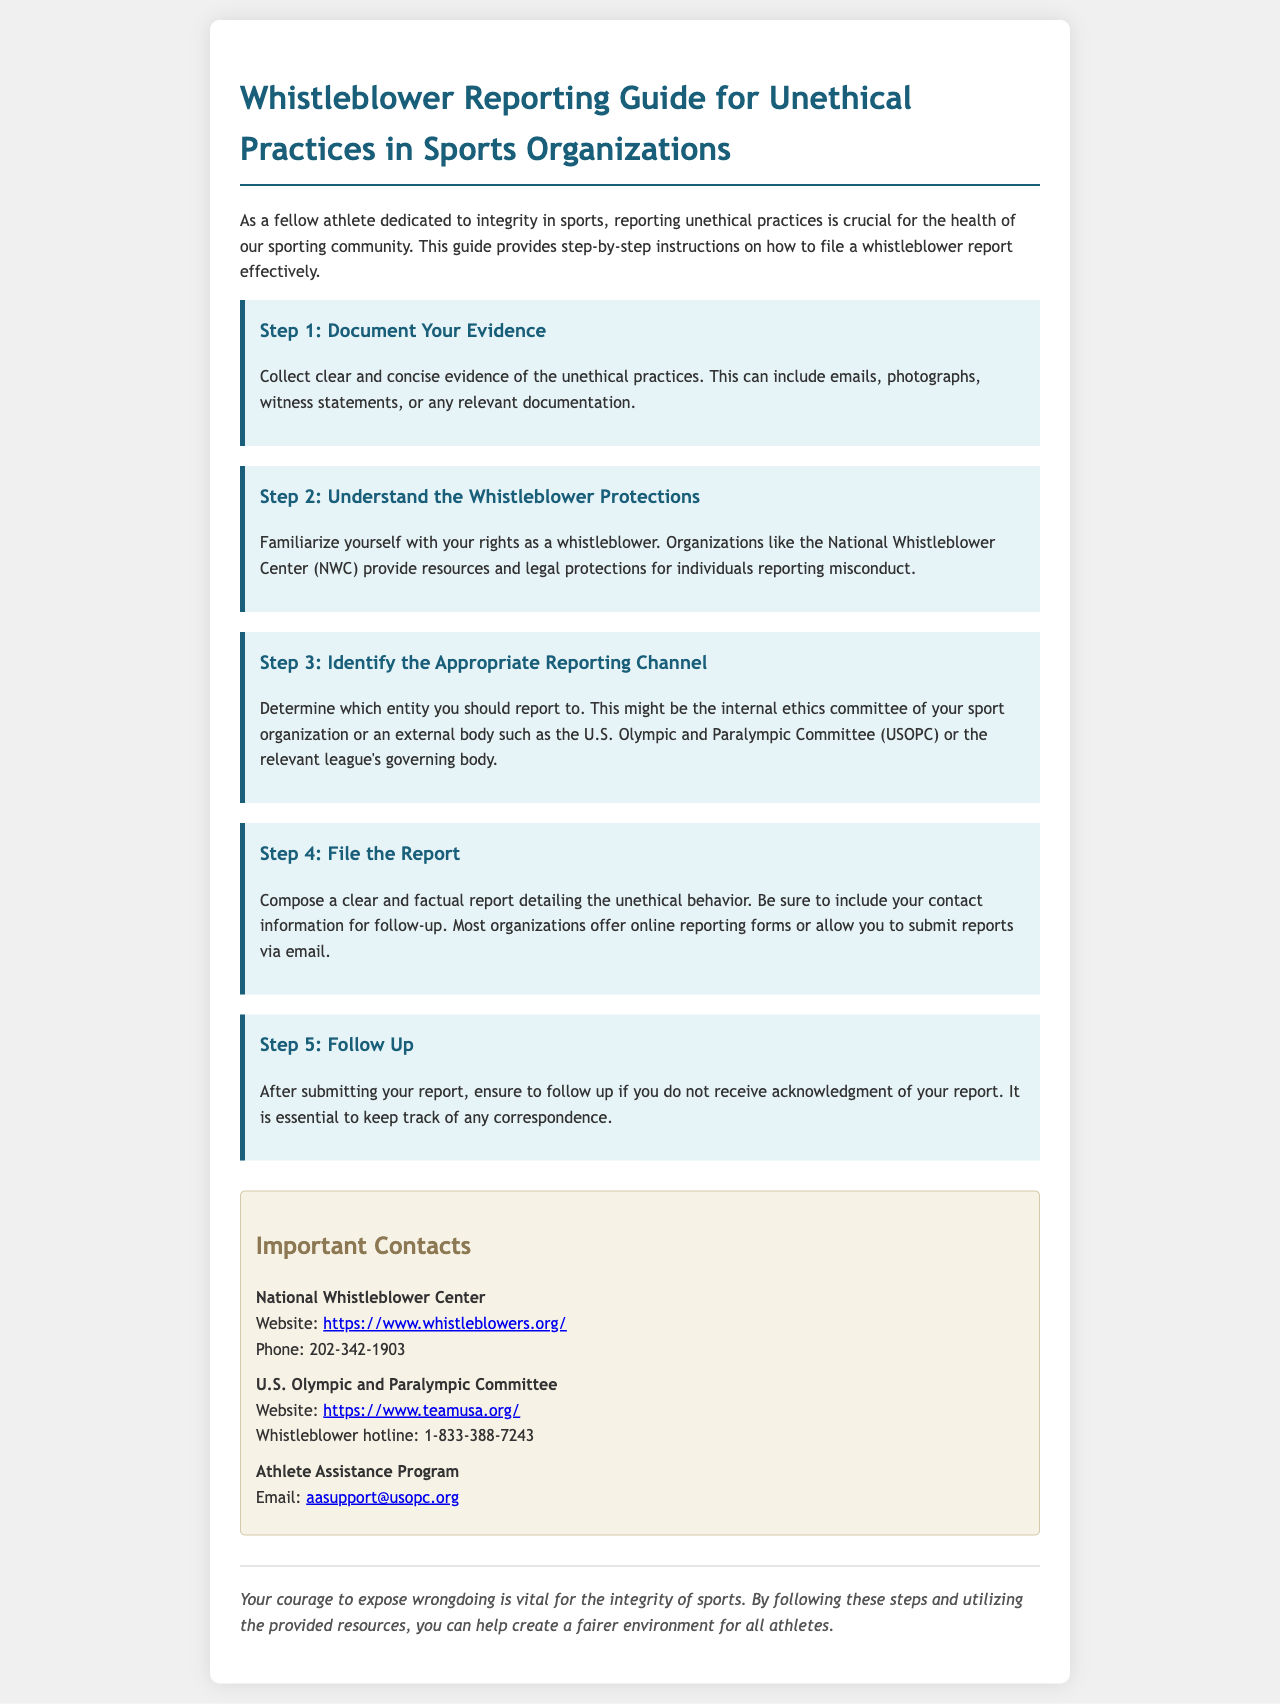What is the title of the guide? The title reflects the main focus of the document which is to provide guidance on reporting unethical practices.
Answer: Whistleblower Reporting Guide for Unethical Practices in Sports Organizations How many steps are included in the reporting process? The steps outline the necessary actions to take for filing a report and are listed clearly in the document.
Answer: Five What is the first step in the reporting process? The first step introduces the importance of collecting evidence before filing a report.
Answer: Document Your Evidence Which organization provides legal protections for whistleblowers? The document mentions specific organizations that offer resources and legal support to whistleblowers.
Answer: National Whistleblower Center What is the contact number for the U.S. Olympic and Paralympic Committee? The document includes specific contact information for relevant organizations in the reporting process.
Answer: 1-833-388-7243 Why is following up after filing a report important? The guide emphasizes the necessity of ensuring that your report has been acknowledged and provides reasons for doing so.
Answer: To keep track of any correspondence What type of format does the document recommend for submitting a report? The document specifies how a report should be composed regarding its content and submission method.
Answer: Clear and factual report What is the email address for the Athlete Assistance Program? The document lists various contact methods, including email, to facilitate communication for athletes needing assistance.
Answer: aasupport@usopc.org 